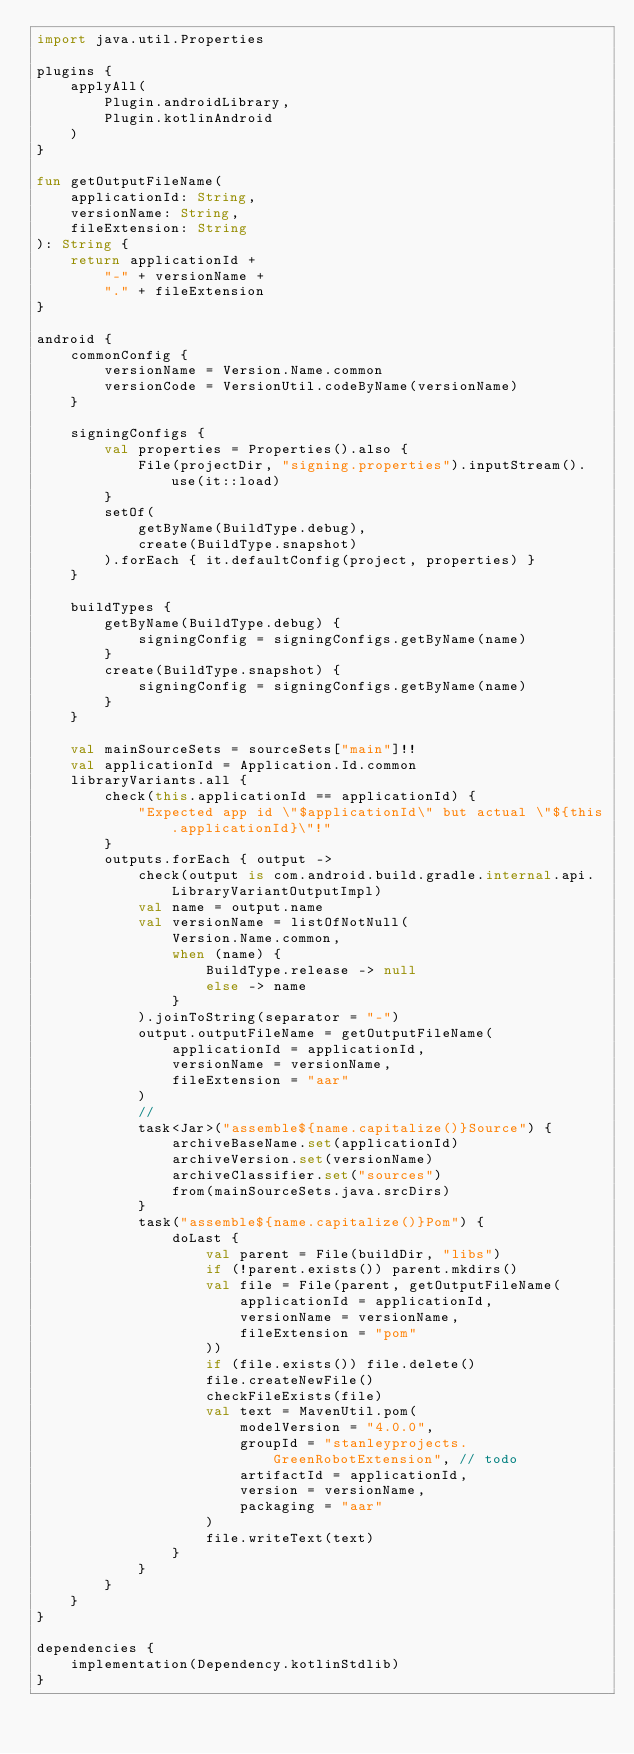<code> <loc_0><loc_0><loc_500><loc_500><_Kotlin_>import java.util.Properties

plugins {
    applyAll(
        Plugin.androidLibrary,
        Plugin.kotlinAndroid
    )
}

fun getOutputFileName(
    applicationId: String,
    versionName: String,
    fileExtension: String
): String {
    return applicationId +
        "-" + versionName +
        "." + fileExtension
}

android {
    commonConfig {
        versionName = Version.Name.common
        versionCode = VersionUtil.codeByName(versionName)
    }

    signingConfigs {
        val properties = Properties().also {
            File(projectDir, "signing.properties").inputStream().use(it::load)
        }
        setOf(
            getByName(BuildType.debug),
            create(BuildType.snapshot)
        ).forEach { it.defaultConfig(project, properties) }
    }

    buildTypes {
        getByName(BuildType.debug) {
            signingConfig = signingConfigs.getByName(name)
        }
        create(BuildType.snapshot) {
            signingConfig = signingConfigs.getByName(name)
        }
    }

    val mainSourceSets = sourceSets["main"]!!
    val applicationId = Application.Id.common
    libraryVariants.all {
        check(this.applicationId == applicationId) {
            "Expected app id \"$applicationId\" but actual \"${this.applicationId}\"!"
        }
        outputs.forEach { output ->
            check(output is com.android.build.gradle.internal.api.LibraryVariantOutputImpl)
            val name = output.name
            val versionName = listOfNotNull(
                Version.Name.common,
                when (name) {
                    BuildType.release -> null
                    else -> name
                }
            ).joinToString(separator = "-")
            output.outputFileName = getOutputFileName(
                applicationId = applicationId,
                versionName = versionName,
                fileExtension = "aar"
            )
            //
            task<Jar>("assemble${name.capitalize()}Source") {
                archiveBaseName.set(applicationId)
                archiveVersion.set(versionName)
                archiveClassifier.set("sources")
                from(mainSourceSets.java.srcDirs)
            }
            task("assemble${name.capitalize()}Pom") {
                doLast {
                    val parent = File(buildDir, "libs")
                    if (!parent.exists()) parent.mkdirs()
                    val file = File(parent, getOutputFileName(
                        applicationId = applicationId,
                        versionName = versionName,
                        fileExtension = "pom"
                    ))
                    if (file.exists()) file.delete()
                    file.createNewFile()
                    checkFileExists(file)
                    val text = MavenUtil.pom(
                        modelVersion = "4.0.0",
                        groupId = "stanleyprojects.GreenRobotExtension", // todo
                        artifactId = applicationId,
                        version = versionName,
                        packaging = "aar"
                    )
                    file.writeText(text)
                }
            }
        }
    }
}

dependencies {
    implementation(Dependency.kotlinStdlib)
}
</code> 